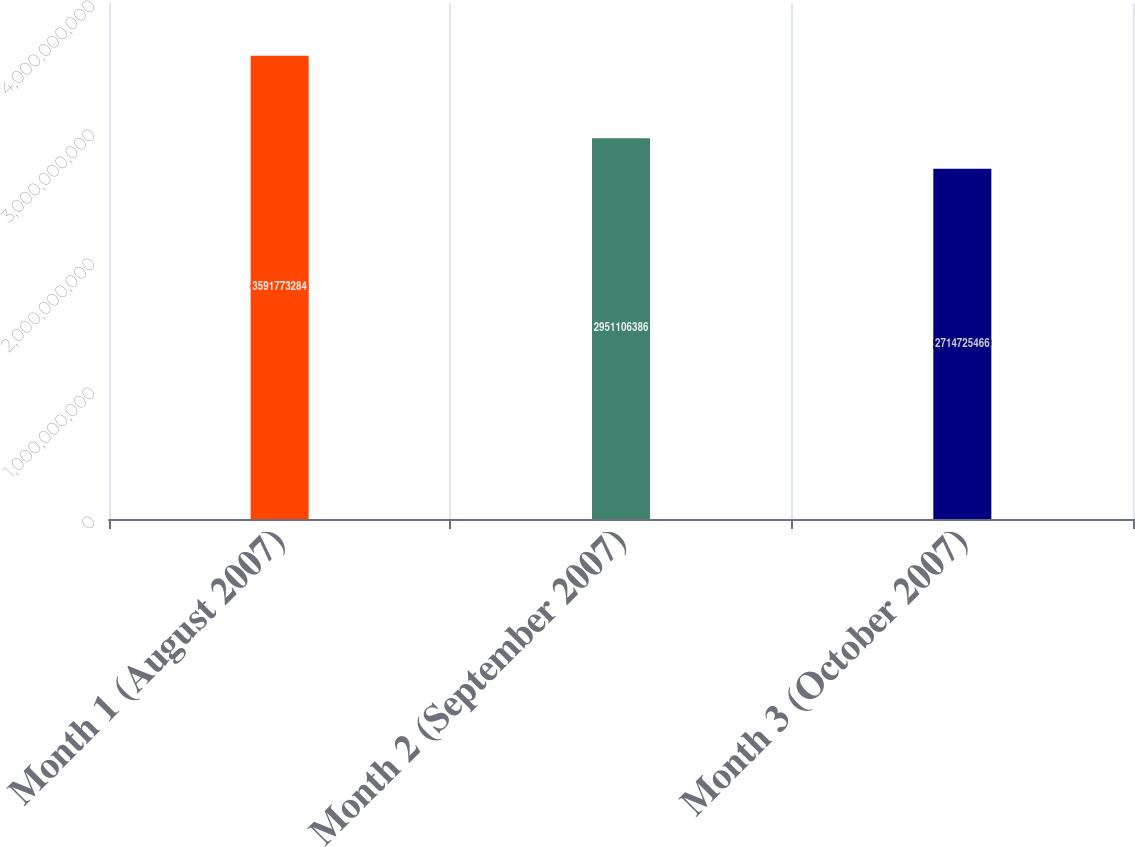<chart> <loc_0><loc_0><loc_500><loc_500><bar_chart><fcel>Month 1 (August 2007)<fcel>Month 2 (September 2007)<fcel>Month 3 (October 2007)<nl><fcel>3.59177e+09<fcel>2.95111e+09<fcel>2.71473e+09<nl></chart> 